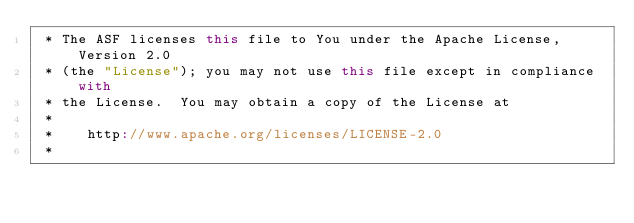<code> <loc_0><loc_0><loc_500><loc_500><_Scala_> * The ASF licenses this file to You under the Apache License, Version 2.0
 * (the "License"); you may not use this file except in compliance with
 * the License.  You may obtain a copy of the License at
 *
 *    http://www.apache.org/licenses/LICENSE-2.0
 *</code> 